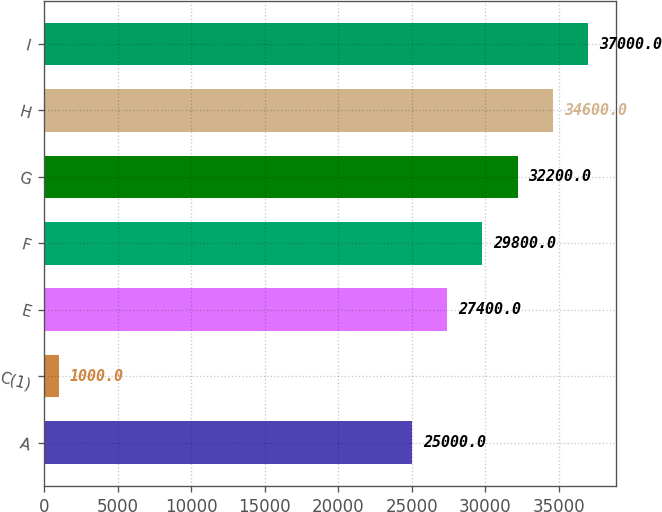<chart> <loc_0><loc_0><loc_500><loc_500><bar_chart><fcel>A<fcel>C(1)<fcel>E<fcel>F<fcel>G<fcel>H<fcel>I<nl><fcel>25000<fcel>1000<fcel>27400<fcel>29800<fcel>32200<fcel>34600<fcel>37000<nl></chart> 